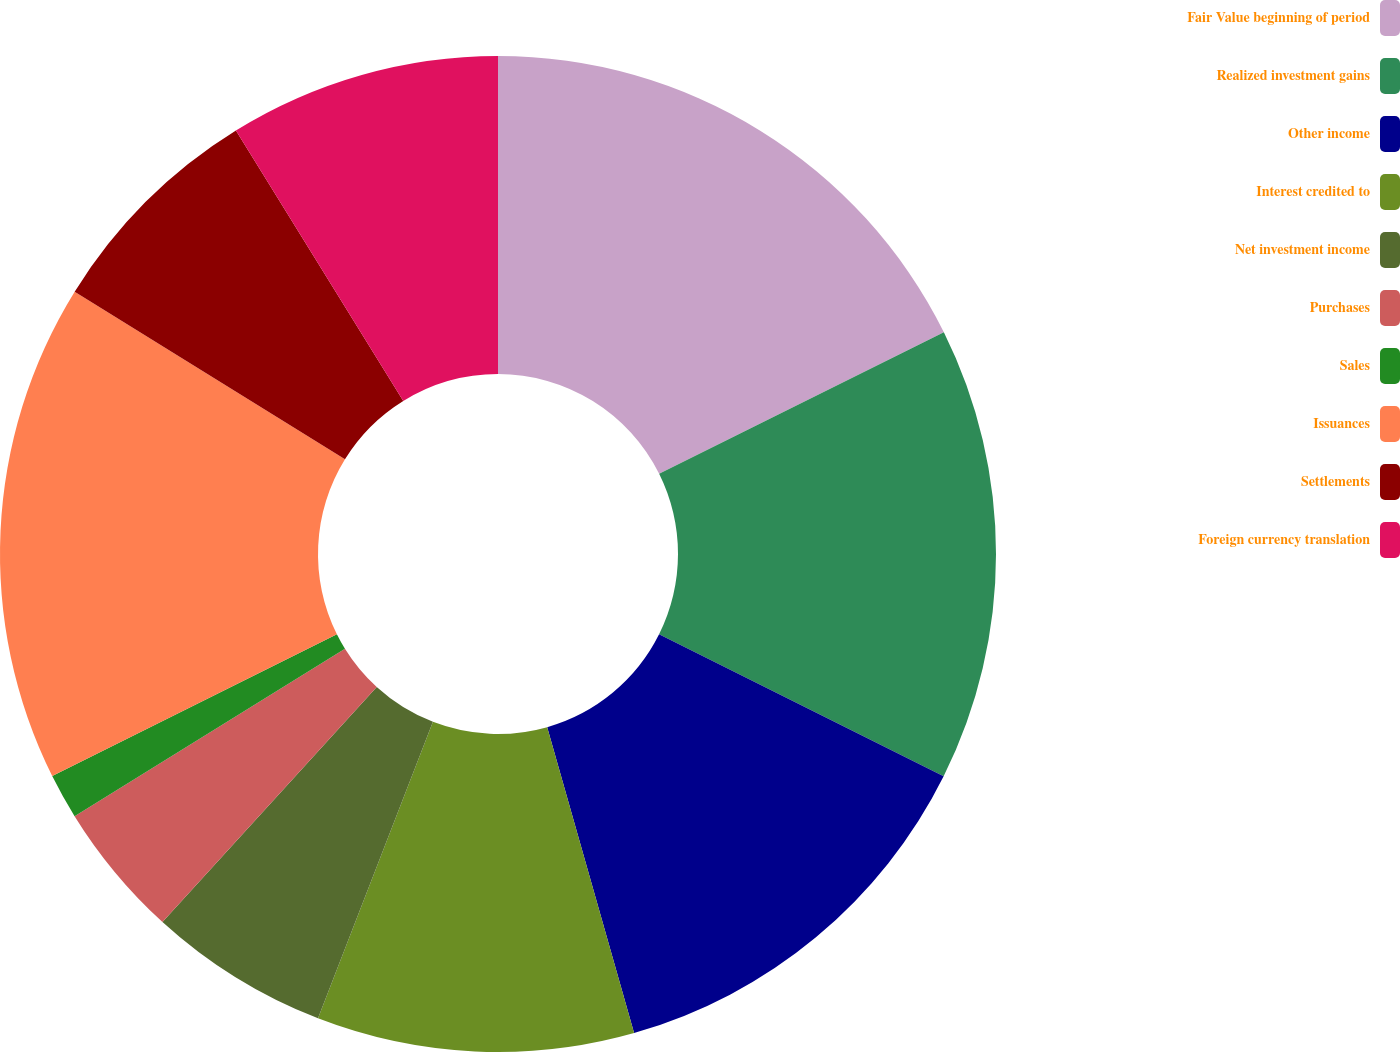Convert chart. <chart><loc_0><loc_0><loc_500><loc_500><pie_chart><fcel>Fair Value beginning of period<fcel>Realized investment gains<fcel>Other income<fcel>Interest credited to<fcel>Net investment income<fcel>Purchases<fcel>Sales<fcel>Issuances<fcel>Settlements<fcel>Foreign currency translation<nl><fcel>17.65%<fcel>14.71%<fcel>13.23%<fcel>10.29%<fcel>5.88%<fcel>4.41%<fcel>1.47%<fcel>16.18%<fcel>7.35%<fcel>8.82%<nl></chart> 